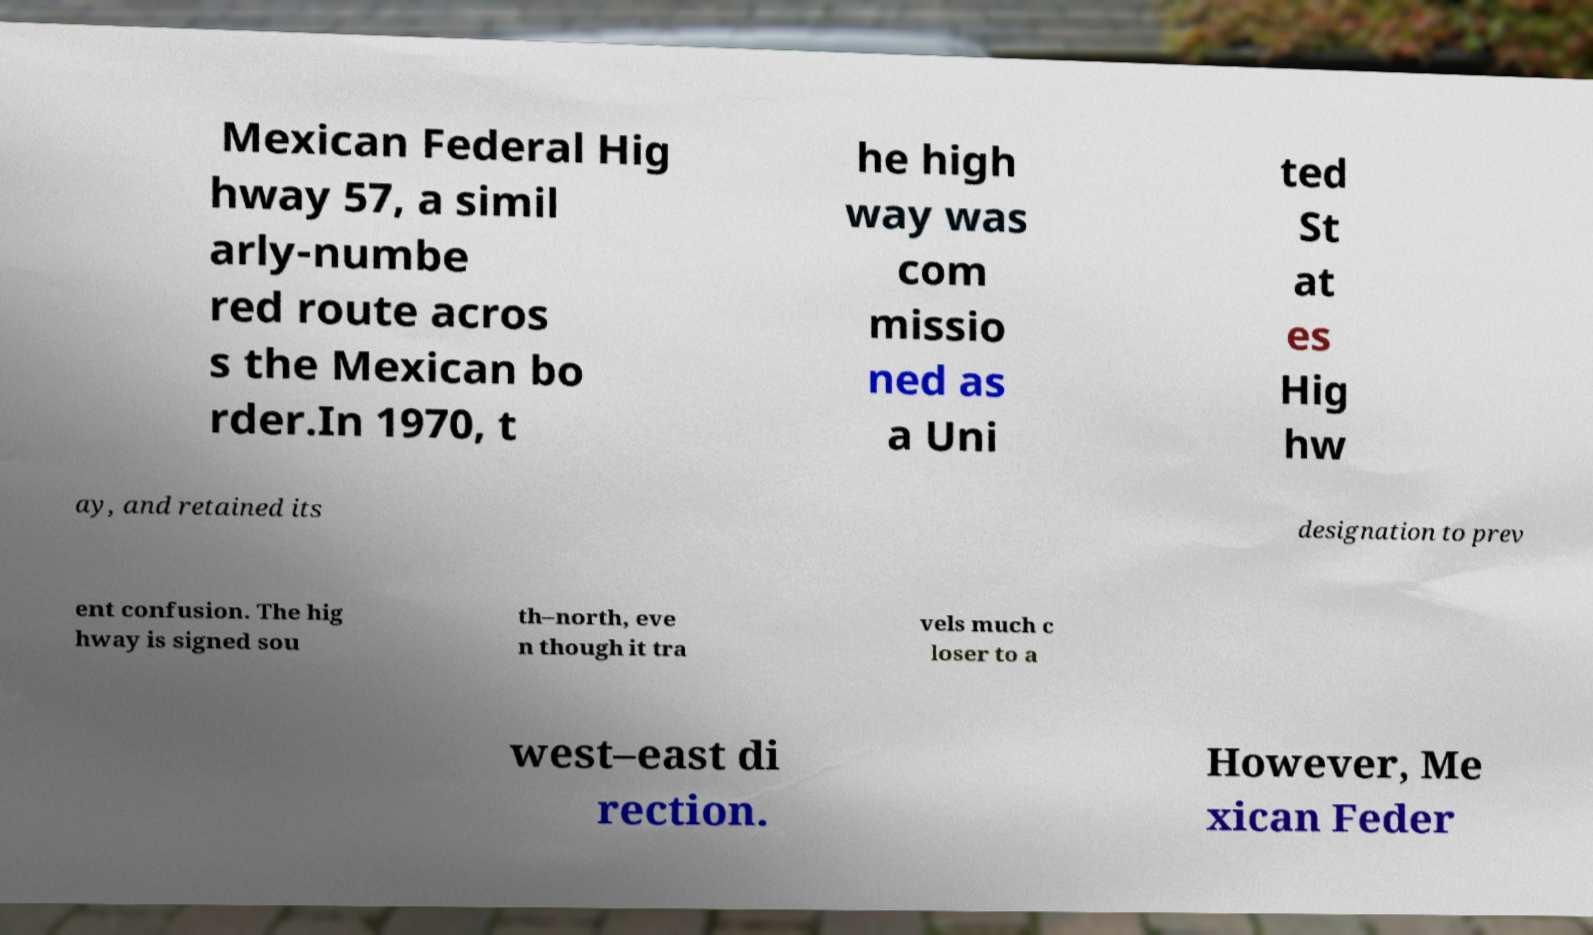Please identify and transcribe the text found in this image. Mexican Federal Hig hway 57, a simil arly-numbe red route acros s the Mexican bo rder.In 1970, t he high way was com missio ned as a Uni ted St at es Hig hw ay, and retained its designation to prev ent confusion. The hig hway is signed sou th–north, eve n though it tra vels much c loser to a west–east di rection. However, Me xican Feder 